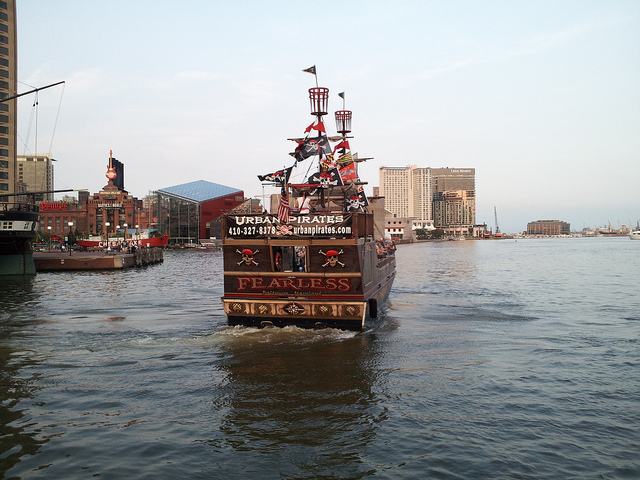Please transcribe the text in this image. URBAN DIRATES 410 327 .8JT8 PEARLESS urbanpirates.com 